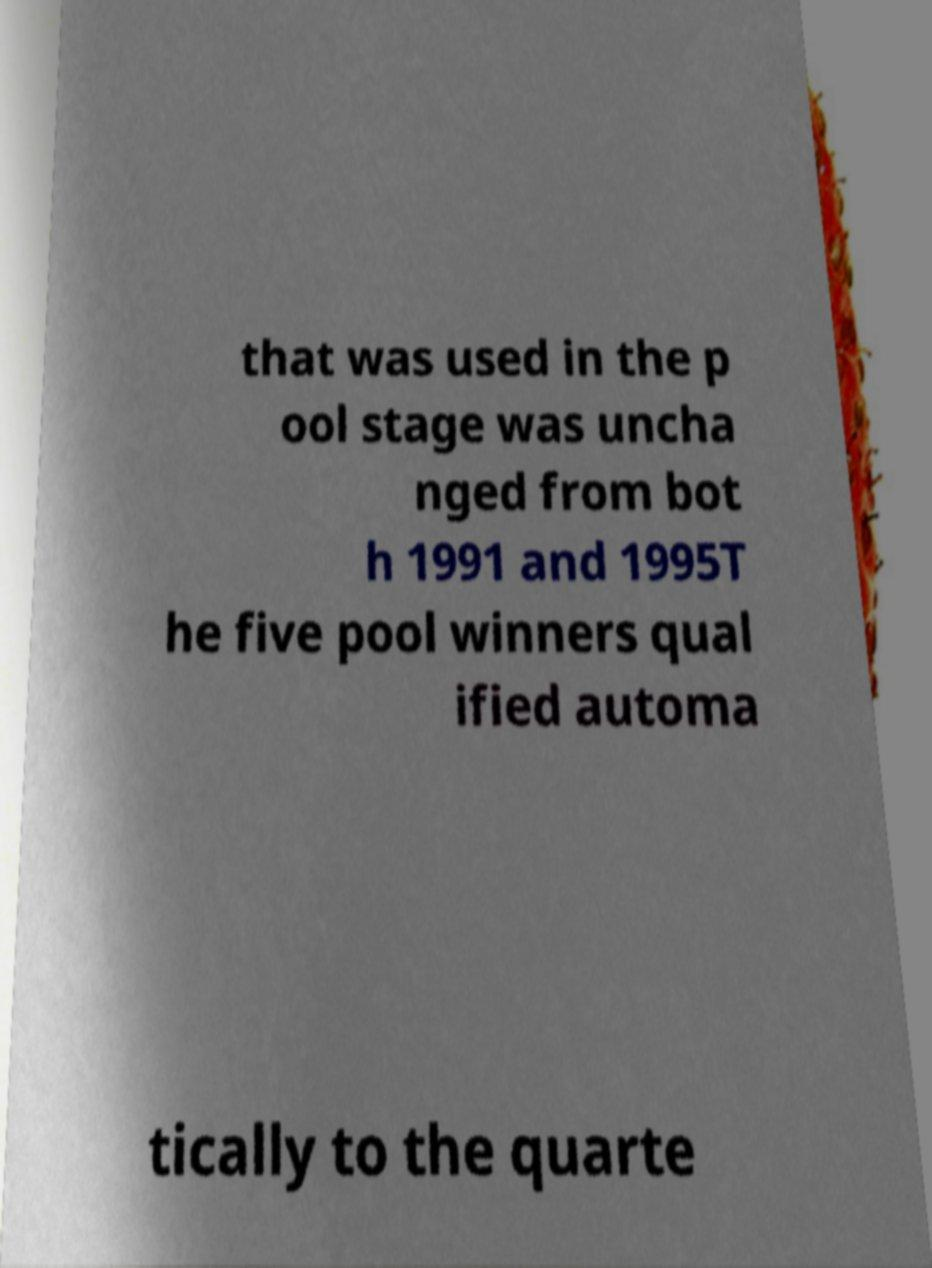For documentation purposes, I need the text within this image transcribed. Could you provide that? that was used in the p ool stage was uncha nged from bot h 1991 and 1995T he five pool winners qual ified automa tically to the quarte 